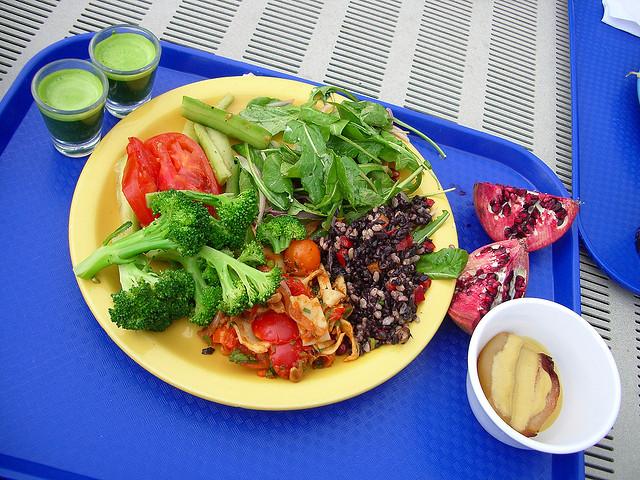What color is the plate with the broccoli?
Short answer required. Yellow. What is the color of the plate?
Be succinct. Yellow. What color is the drink?
Write a very short answer. Green. 